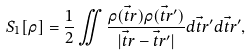Convert formula to latex. <formula><loc_0><loc_0><loc_500><loc_500>S _ { 1 } [ \rho ] = \frac { 1 } { 2 } \iint \frac { \rho ( \vec { t } { r } ) \rho ( \vec { t } { r } ^ { \prime } ) } { | \vec { t } { r } - \vec { t } { r } ^ { \prime } | } d \vec { t } { r } ^ { \prime } d \vec { t } { r } ^ { \prime } ,</formula> 